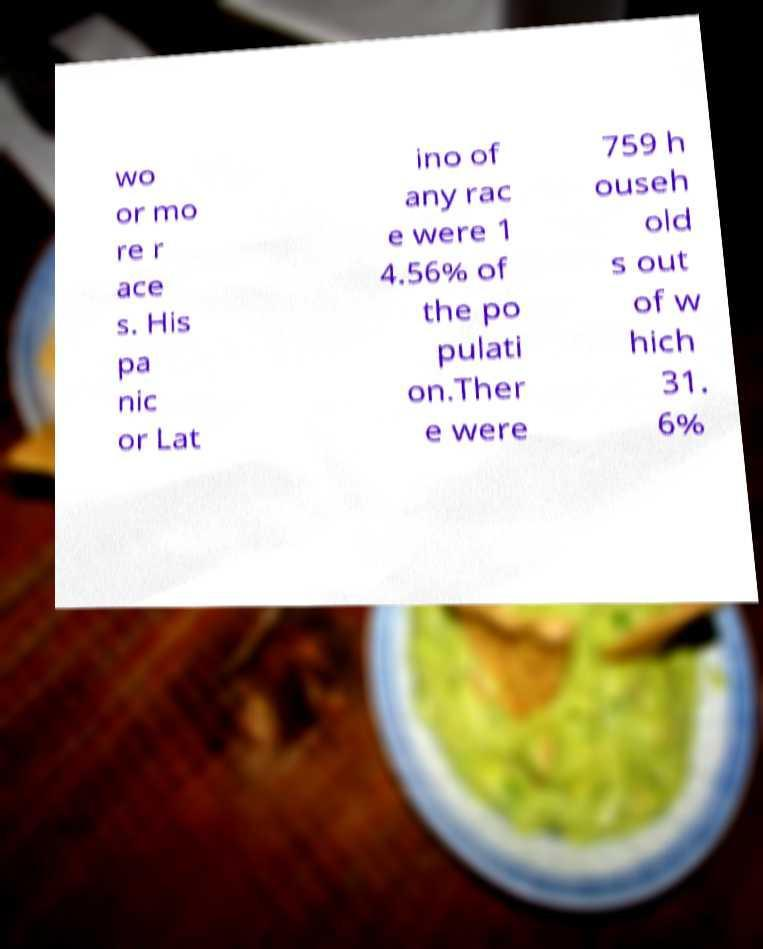Can you accurately transcribe the text from the provided image for me? wo or mo re r ace s. His pa nic or Lat ino of any rac e were 1 4.56% of the po pulati on.Ther e were 759 h ouseh old s out of w hich 31. 6% 